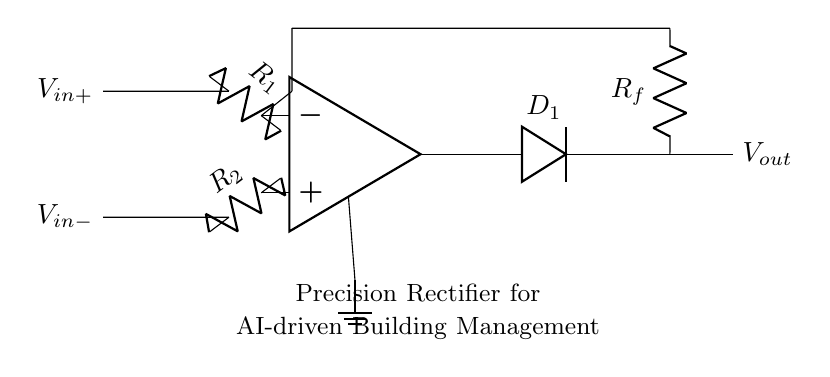What are the input voltages for the precision rectifier? The input voltages are labeled as V_in+ and V_in-. These are the two points at which the input signals are applied to the non-inverting and inverting terminals of the operational amplifier.
Answer: V_in+ and V_in- What type of diode is used in this circuit? The circuit diagram labels the diode as D_1. This indicates the presence of a standard diode typically used for rectification purposes.
Answer: D_1 What is the function of the operational amplifier in this circuit? The operational amplifier amplifies the difference between the input voltages applied to its inverting and non-inverting terminals. In a precision rectifier, it ensures accurate rectification even for small input signals.
Answer: Amplification What is the value of the feedback resistor denoted in the circuit? The feedback resistor is labeled as R_f, and the circuit does not provide a numerical value, so it is assumed to be variable or unspecified.
Answer: R_f How is the output voltage calculated in this precision rectifier circuit? The output voltage V_out is determined based on the amplified difference between V_in+ and V_in-, modified by the diode's conduction state, which allows only positive output during the rectification process. The specifics depend on the values of R_1, R_2, and R_f.
Answer: Through amplification and rectification What is the ground reference in the circuit? The ground reference is indicated by the ground symbol at the bottom of the operational amplifier, connecting to the op-amp's negative terminal. This is critical for establishing a common reference point for the circuit.
Answer: Ground What happens when V_in+ is less than V_in-? When V_in+ is less than V_in-, the operational amplifier output will go low, and the diode D_1 will be reverse biased, resulting in no current flow and thus V_out will be zero.
Answer: V_out = zero 